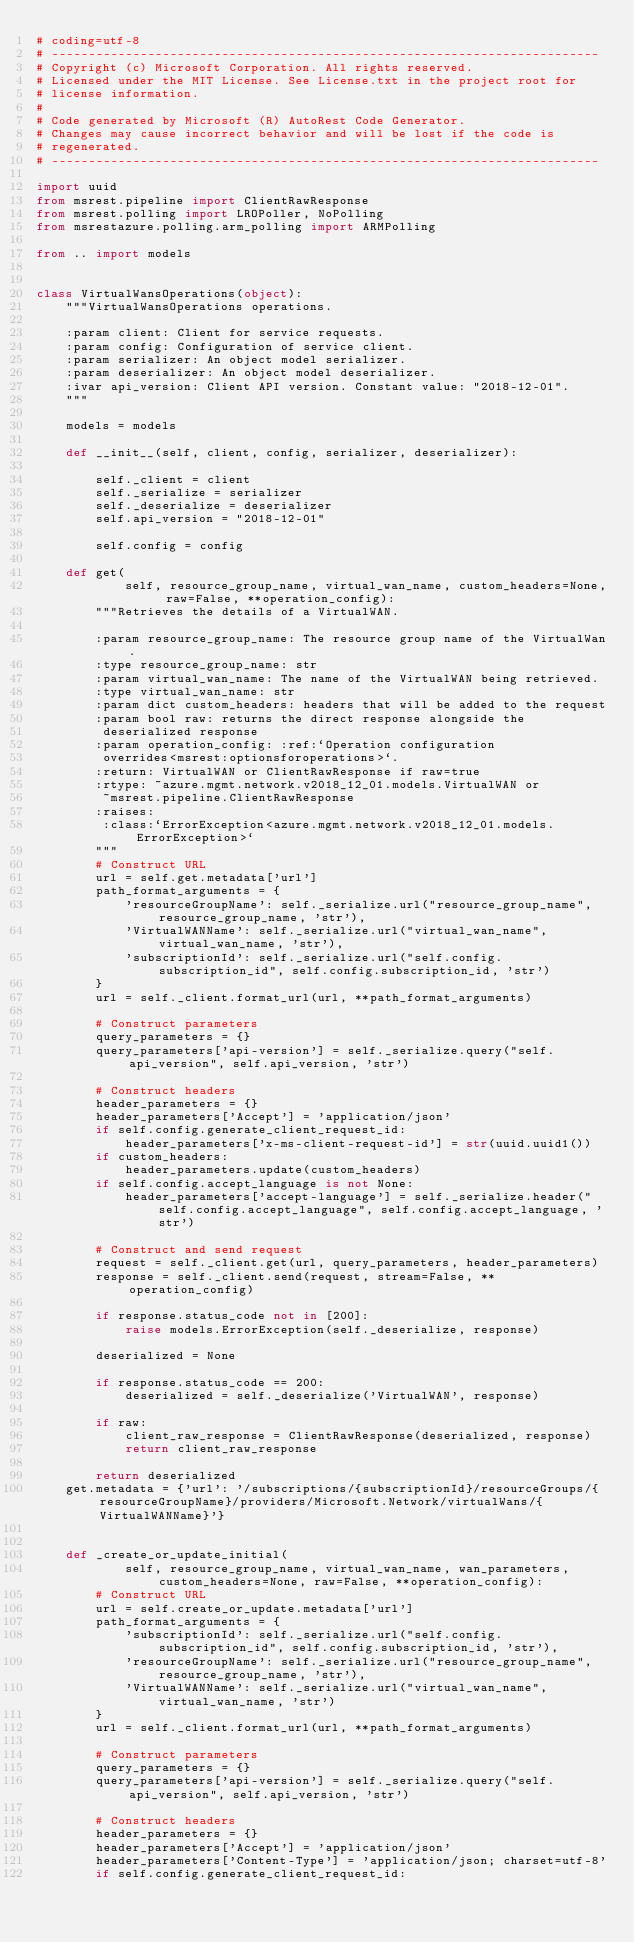Convert code to text. <code><loc_0><loc_0><loc_500><loc_500><_Python_># coding=utf-8
# --------------------------------------------------------------------------
# Copyright (c) Microsoft Corporation. All rights reserved.
# Licensed under the MIT License. See License.txt in the project root for
# license information.
#
# Code generated by Microsoft (R) AutoRest Code Generator.
# Changes may cause incorrect behavior and will be lost if the code is
# regenerated.
# --------------------------------------------------------------------------

import uuid
from msrest.pipeline import ClientRawResponse
from msrest.polling import LROPoller, NoPolling
from msrestazure.polling.arm_polling import ARMPolling

from .. import models


class VirtualWansOperations(object):
    """VirtualWansOperations operations.

    :param client: Client for service requests.
    :param config: Configuration of service client.
    :param serializer: An object model serializer.
    :param deserializer: An object model deserializer.
    :ivar api_version: Client API version. Constant value: "2018-12-01".
    """

    models = models

    def __init__(self, client, config, serializer, deserializer):

        self._client = client
        self._serialize = serializer
        self._deserialize = deserializer
        self.api_version = "2018-12-01"

        self.config = config

    def get(
            self, resource_group_name, virtual_wan_name, custom_headers=None, raw=False, **operation_config):
        """Retrieves the details of a VirtualWAN.

        :param resource_group_name: The resource group name of the VirtualWan.
        :type resource_group_name: str
        :param virtual_wan_name: The name of the VirtualWAN being retrieved.
        :type virtual_wan_name: str
        :param dict custom_headers: headers that will be added to the request
        :param bool raw: returns the direct response alongside the
         deserialized response
        :param operation_config: :ref:`Operation configuration
         overrides<msrest:optionsforoperations>`.
        :return: VirtualWAN or ClientRawResponse if raw=true
        :rtype: ~azure.mgmt.network.v2018_12_01.models.VirtualWAN or
         ~msrest.pipeline.ClientRawResponse
        :raises:
         :class:`ErrorException<azure.mgmt.network.v2018_12_01.models.ErrorException>`
        """
        # Construct URL
        url = self.get.metadata['url']
        path_format_arguments = {
            'resourceGroupName': self._serialize.url("resource_group_name", resource_group_name, 'str'),
            'VirtualWANName': self._serialize.url("virtual_wan_name", virtual_wan_name, 'str'),
            'subscriptionId': self._serialize.url("self.config.subscription_id", self.config.subscription_id, 'str')
        }
        url = self._client.format_url(url, **path_format_arguments)

        # Construct parameters
        query_parameters = {}
        query_parameters['api-version'] = self._serialize.query("self.api_version", self.api_version, 'str')

        # Construct headers
        header_parameters = {}
        header_parameters['Accept'] = 'application/json'
        if self.config.generate_client_request_id:
            header_parameters['x-ms-client-request-id'] = str(uuid.uuid1())
        if custom_headers:
            header_parameters.update(custom_headers)
        if self.config.accept_language is not None:
            header_parameters['accept-language'] = self._serialize.header("self.config.accept_language", self.config.accept_language, 'str')

        # Construct and send request
        request = self._client.get(url, query_parameters, header_parameters)
        response = self._client.send(request, stream=False, **operation_config)

        if response.status_code not in [200]:
            raise models.ErrorException(self._deserialize, response)

        deserialized = None

        if response.status_code == 200:
            deserialized = self._deserialize('VirtualWAN', response)

        if raw:
            client_raw_response = ClientRawResponse(deserialized, response)
            return client_raw_response

        return deserialized
    get.metadata = {'url': '/subscriptions/{subscriptionId}/resourceGroups/{resourceGroupName}/providers/Microsoft.Network/virtualWans/{VirtualWANName}'}


    def _create_or_update_initial(
            self, resource_group_name, virtual_wan_name, wan_parameters, custom_headers=None, raw=False, **operation_config):
        # Construct URL
        url = self.create_or_update.metadata['url']
        path_format_arguments = {
            'subscriptionId': self._serialize.url("self.config.subscription_id", self.config.subscription_id, 'str'),
            'resourceGroupName': self._serialize.url("resource_group_name", resource_group_name, 'str'),
            'VirtualWANName': self._serialize.url("virtual_wan_name", virtual_wan_name, 'str')
        }
        url = self._client.format_url(url, **path_format_arguments)

        # Construct parameters
        query_parameters = {}
        query_parameters['api-version'] = self._serialize.query("self.api_version", self.api_version, 'str')

        # Construct headers
        header_parameters = {}
        header_parameters['Accept'] = 'application/json'
        header_parameters['Content-Type'] = 'application/json; charset=utf-8'
        if self.config.generate_client_request_id:</code> 